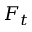<formula> <loc_0><loc_0><loc_500><loc_500>F _ { t }</formula> 